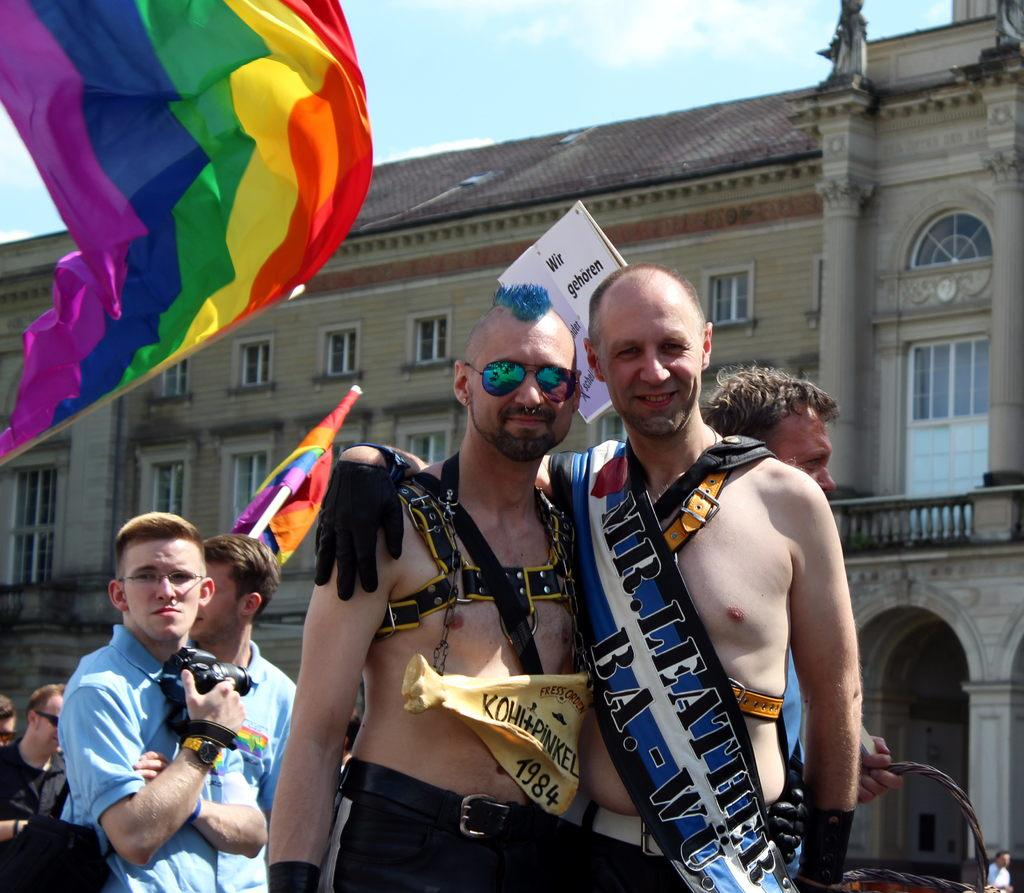Who or what can be seen in the image? There are people in the image. What can be seen besides the people? There are flags, a poster, a building, pillars, windows, and the sky visible in the background of the image. What is the weather like in the image? The sky is visible in the background of the image, and clouds are present, suggesting a partly cloudy day. What type of blade is being used in the meeting depicted in the image? There is no meeting or blade present in the image. What is the sound of thunder like in the image? There is no mention of thunder or any sound in the image. 